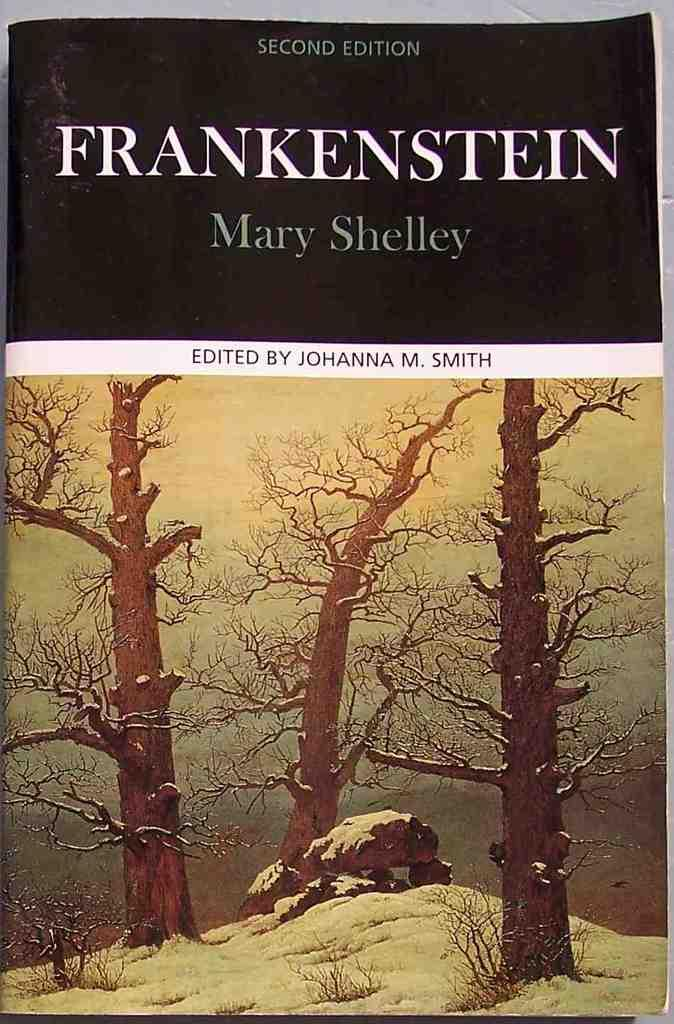<image>
Give a short and clear explanation of the subsequent image. Frankenstein by Mary Shelly is an interesting read, full of suspense. 